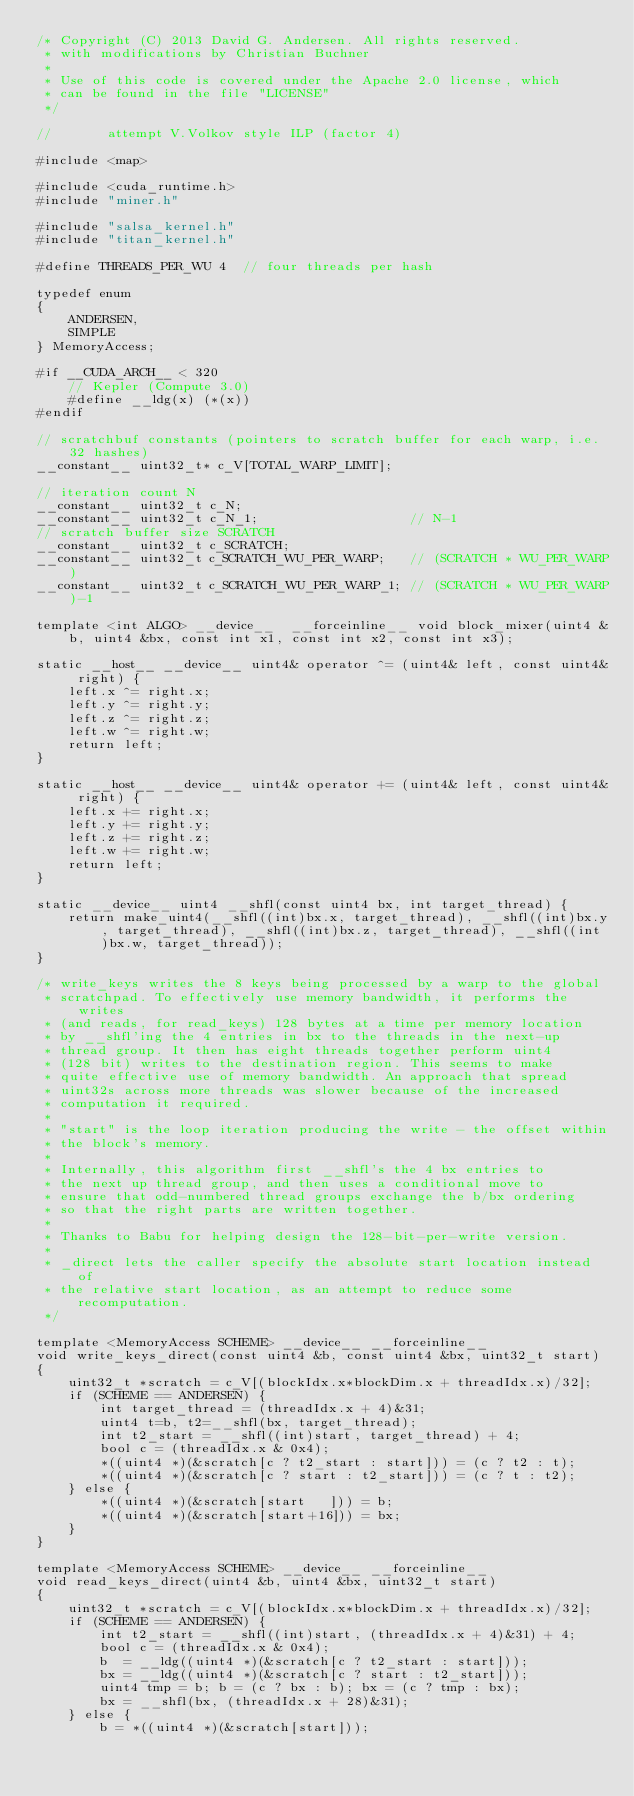<code> <loc_0><loc_0><loc_500><loc_500><_Cuda_>/* Copyright (C) 2013 David G. Andersen. All rights reserved.
 * with modifications by Christian Buchner
 *
 * Use of this code is covered under the Apache 2.0 license, which
 * can be found in the file "LICENSE"
 */

//       attempt V.Volkov style ILP (factor 4)

#include <map>

#include <cuda_runtime.h>
#include "miner.h"

#include "salsa_kernel.h"
#include "titan_kernel.h"

#define THREADS_PER_WU 4  // four threads per hash

typedef enum
{
	ANDERSEN,
	SIMPLE
} MemoryAccess;

#if __CUDA_ARCH__ < 320
	// Kepler (Compute 3.0)
	#define __ldg(x) (*(x))
#endif

// scratchbuf constants (pointers to scratch buffer for each warp, i.e. 32 hashes)
__constant__ uint32_t* c_V[TOTAL_WARP_LIMIT];

// iteration count N
__constant__ uint32_t c_N;
__constant__ uint32_t c_N_1;                   // N-1
// scratch buffer size SCRATCH
__constant__ uint32_t c_SCRATCH;
__constant__ uint32_t c_SCRATCH_WU_PER_WARP;   // (SCRATCH * WU_PER_WARP)
__constant__ uint32_t c_SCRATCH_WU_PER_WARP_1; // (SCRATCH * WU_PER_WARP)-1

template <int ALGO> __device__  __forceinline__ void block_mixer(uint4 &b, uint4 &bx, const int x1, const int x2, const int x3);

static __host__ __device__ uint4& operator ^= (uint4& left, const uint4& right) {
	left.x ^= right.x;
	left.y ^= right.y;
	left.z ^= right.z;
	left.w ^= right.w;
	return left;
}

static __host__ __device__ uint4& operator += (uint4& left, const uint4& right) {
	left.x += right.x;
	left.y += right.y;
	left.z += right.z;
	left.w += right.w;
	return left;
}

static __device__ uint4 __shfl(const uint4 bx, int target_thread) {
	return make_uint4(__shfl((int)bx.x, target_thread), __shfl((int)bx.y, target_thread), __shfl((int)bx.z, target_thread), __shfl((int)bx.w, target_thread));
}

/* write_keys writes the 8 keys being processed by a warp to the global
 * scratchpad. To effectively use memory bandwidth, it performs the writes
 * (and reads, for read_keys) 128 bytes at a time per memory location
 * by __shfl'ing the 4 entries in bx to the threads in the next-up
 * thread group. It then has eight threads together perform uint4
 * (128 bit) writes to the destination region. This seems to make
 * quite effective use of memory bandwidth. An approach that spread
 * uint32s across more threads was slower because of the increased
 * computation it required.
 *
 * "start" is the loop iteration producing the write - the offset within
 * the block's memory.
 *
 * Internally, this algorithm first __shfl's the 4 bx entries to
 * the next up thread group, and then uses a conditional move to
 * ensure that odd-numbered thread groups exchange the b/bx ordering
 * so that the right parts are written together.
 *
 * Thanks to Babu for helping design the 128-bit-per-write version.
 *
 * _direct lets the caller specify the absolute start location instead of
 * the relative start location, as an attempt to reduce some recomputation.
 */

template <MemoryAccess SCHEME> __device__ __forceinline__
void write_keys_direct(const uint4 &b, const uint4 &bx, uint32_t start)
{
	uint32_t *scratch = c_V[(blockIdx.x*blockDim.x + threadIdx.x)/32];
	if (SCHEME == ANDERSEN) {
		int target_thread = (threadIdx.x + 4)&31;
		uint4 t=b, t2=__shfl(bx, target_thread);
		int t2_start = __shfl((int)start, target_thread) + 4;
		bool c = (threadIdx.x & 0x4);
		*((uint4 *)(&scratch[c ? t2_start : start])) = (c ? t2 : t);
		*((uint4 *)(&scratch[c ? start : t2_start])) = (c ? t : t2);
	} else {
		*((uint4 *)(&scratch[start   ])) = b;
		*((uint4 *)(&scratch[start+16])) = bx;
	}
}

template <MemoryAccess SCHEME> __device__ __forceinline__
void read_keys_direct(uint4 &b, uint4 &bx, uint32_t start)
{
	uint32_t *scratch = c_V[(blockIdx.x*blockDim.x + threadIdx.x)/32];
	if (SCHEME == ANDERSEN) {
		int t2_start = __shfl((int)start, (threadIdx.x + 4)&31) + 4;
		bool c = (threadIdx.x & 0x4);
		b  = __ldg((uint4 *)(&scratch[c ? t2_start : start]));
		bx = __ldg((uint4 *)(&scratch[c ? start : t2_start]));
		uint4 tmp = b; b = (c ? bx : b); bx = (c ? tmp : bx);
		bx = __shfl(bx, (threadIdx.x + 28)&31);
	} else {
		b = *((uint4 *)(&scratch[start]));</code> 